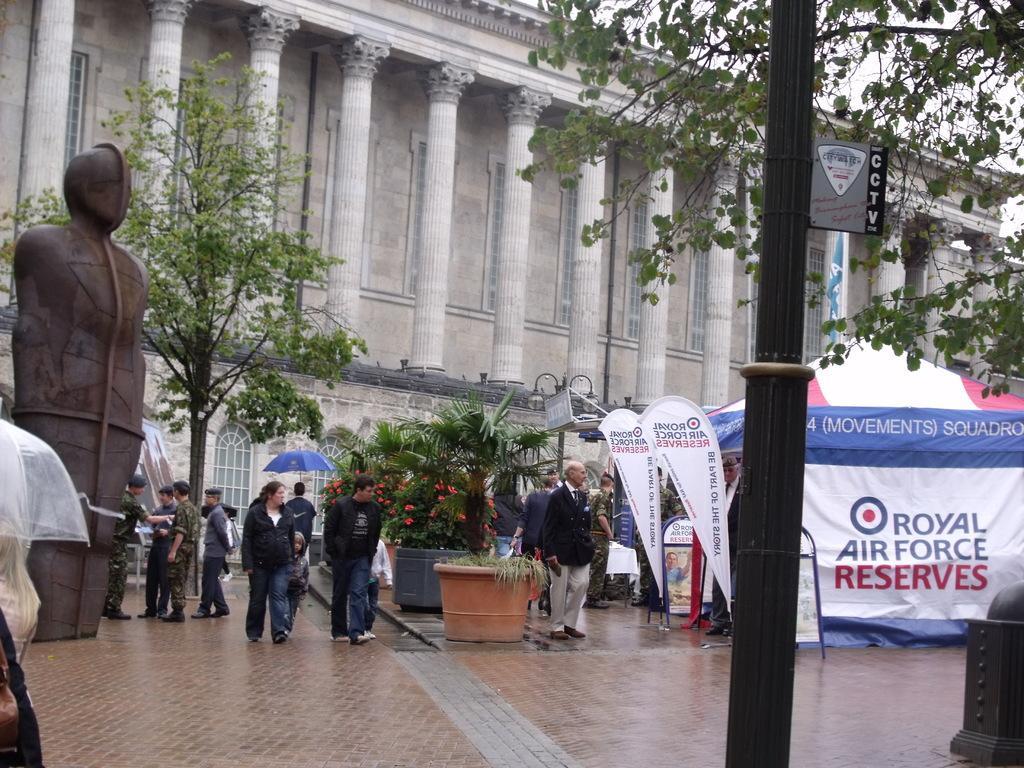Can you describe this image briefly? In this image there is a building and we can see trees. There are people. On the left we can see a sculpture and there are umbrellas. On the right there is a tent. We can see banners. In the background there is sky. 